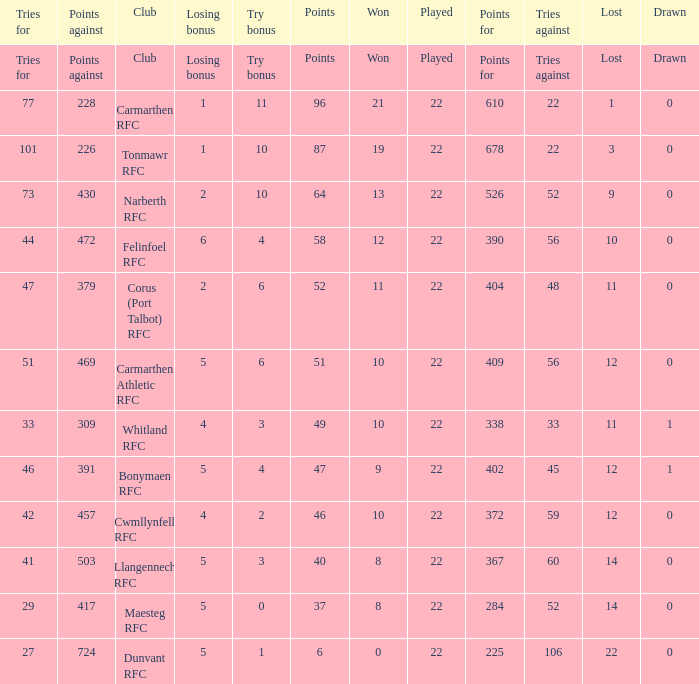Name the losing bonus for 27 5.0. 